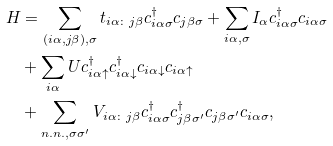<formula> <loc_0><loc_0><loc_500><loc_500>H & = \sum _ { ( i \alpha , j \beta ) , \sigma } t _ { i \alpha \colon j \beta } c ^ { \dag } _ { i \alpha \sigma } c _ { j \beta \sigma } + \sum _ { i \alpha , \sigma } I _ { \alpha } c ^ { \dag } _ { i \alpha \sigma } c _ { i \alpha \sigma } \\ & + \sum _ { i \alpha } U c ^ { \dag } _ { i \alpha \uparrow } c ^ { \dag } _ { i \alpha \downarrow } c _ { i \alpha \downarrow } c _ { i \alpha \uparrow } \\ & + \sum _ { n . n . , \sigma \sigma ^ { \prime } } V _ { i \alpha \colon j \beta } c ^ { \dag } _ { i \alpha \sigma } c ^ { \dag } _ { j \beta \sigma ^ { \prime } } c _ { j \beta \sigma ^ { \prime } } c _ { i \alpha \sigma } ,</formula> 